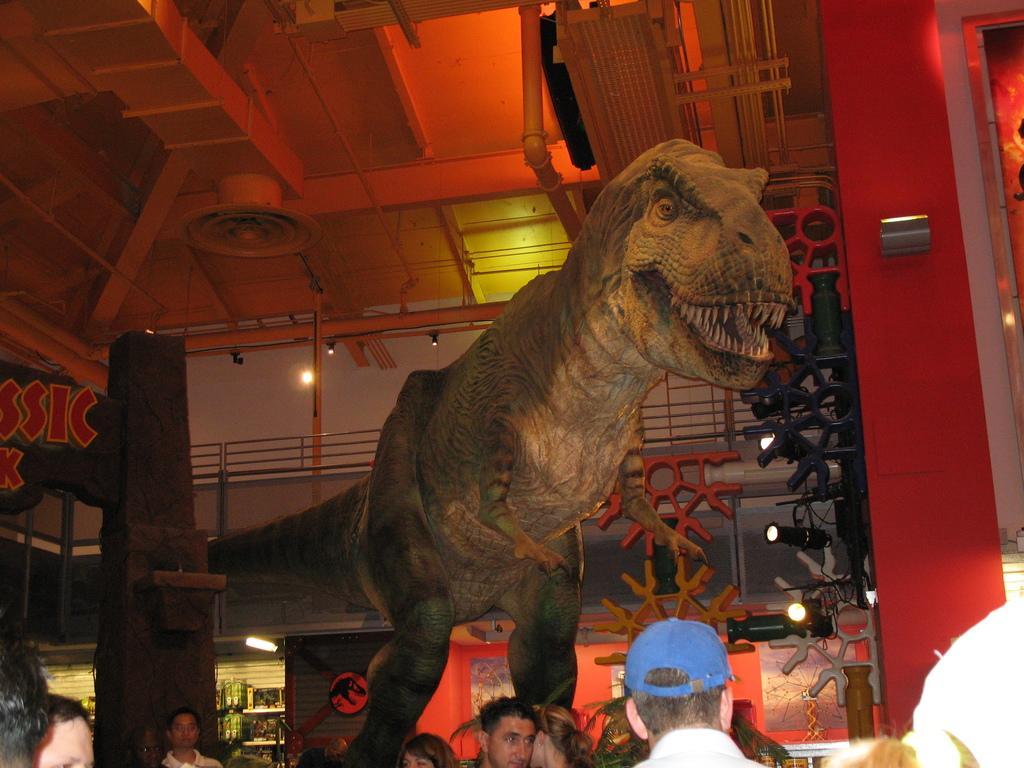Can you describe this image briefly? In this image I can see statue of a dinosaur. There are group of people, there are focus lights, iron grilles, there is a pipe and there are some other objects. 